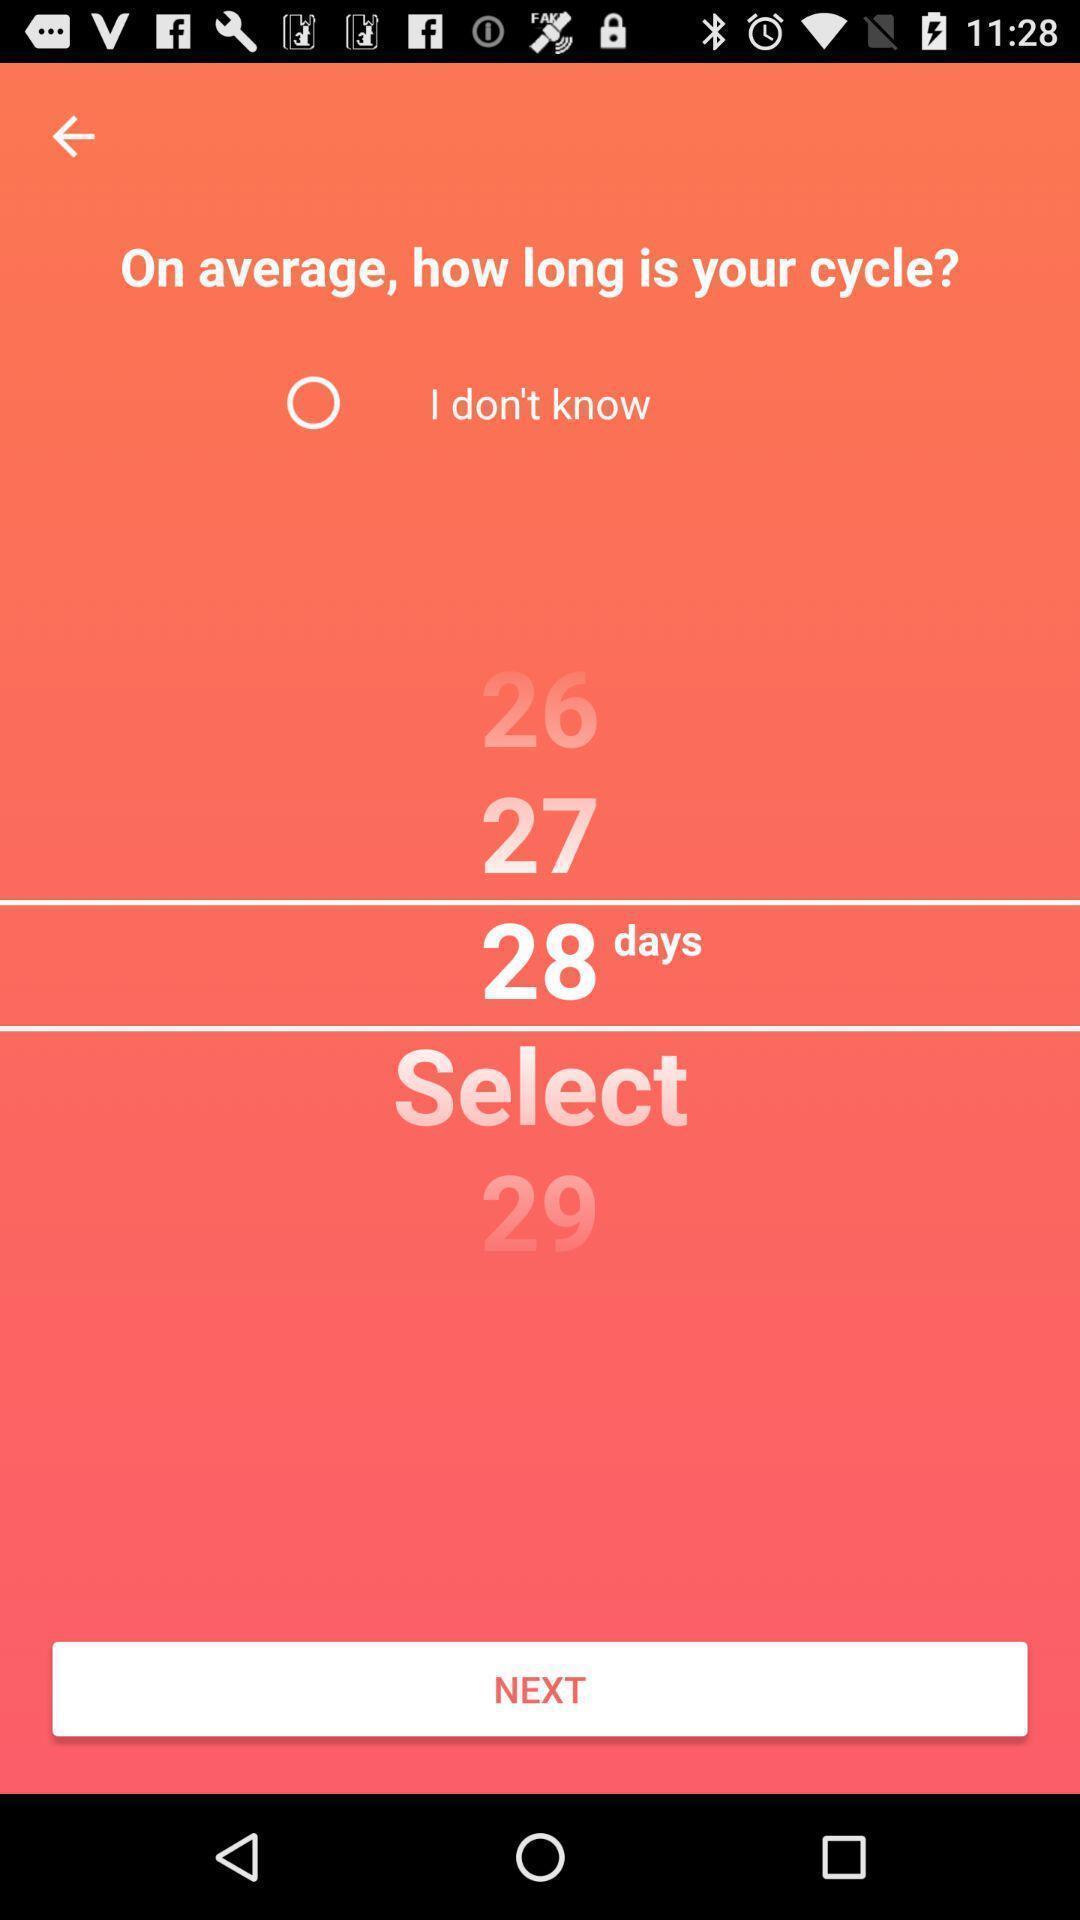Tell me about the visual elements in this screen capture. Screen displaying the list of numbers to select the days. 